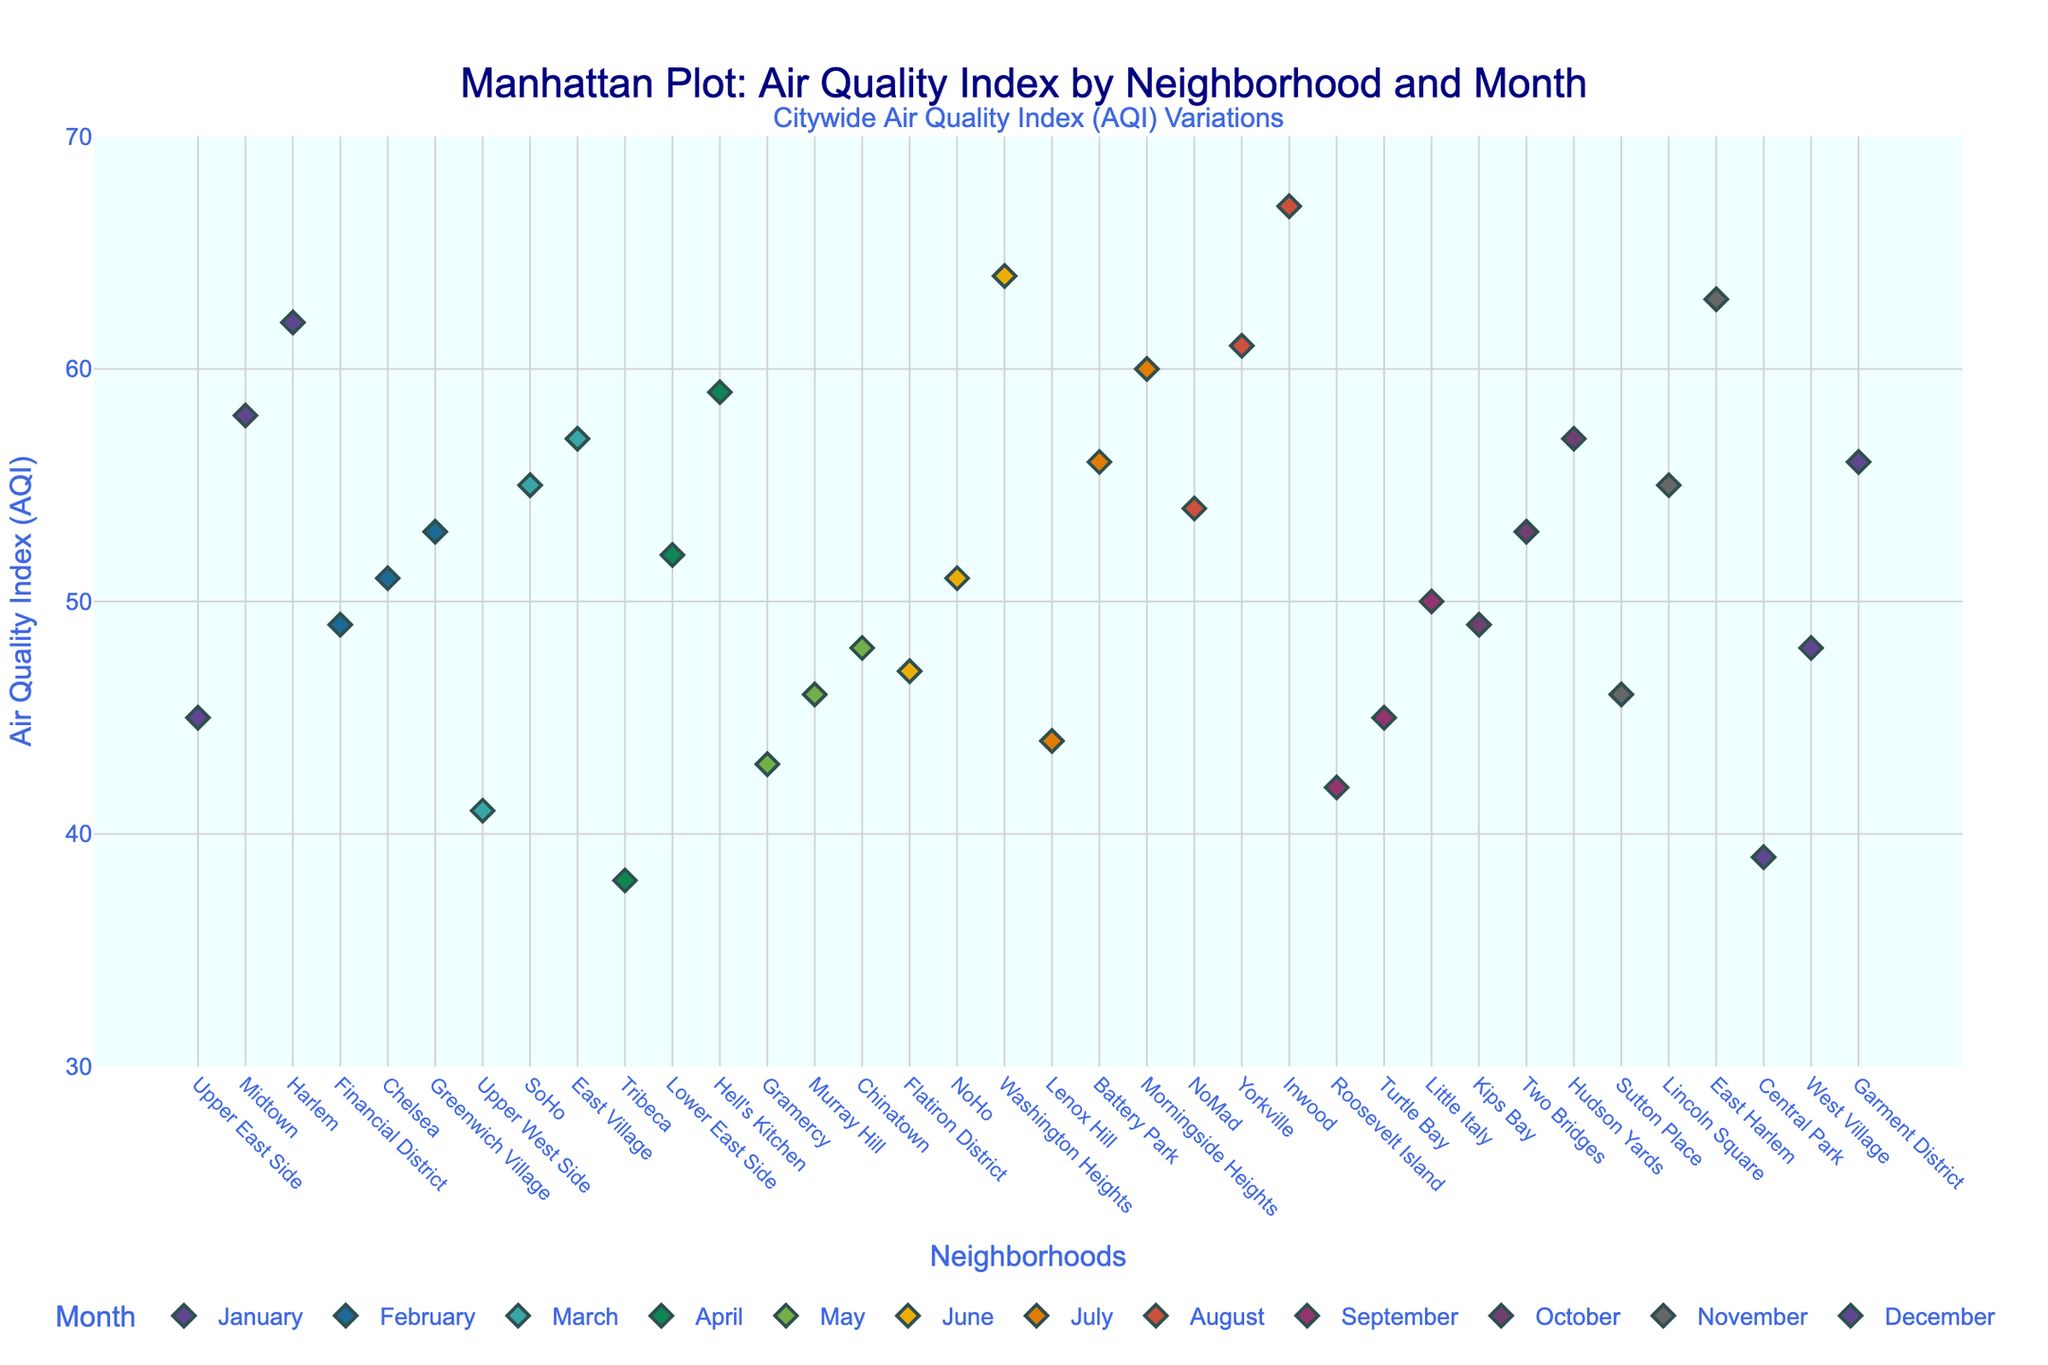Which month has the highest average AQI across all neighborhoods? Looking at the plot, identify the month with the highest average AQI by visually comparing the heights of the markers for each month. August has generally higher AQI values.
Answer: August Which neighborhood had the highest AQI in January? Look for the highest marker in January. Harlem stands out with an AQI of 62.
Answer: Harlem Which months exhibit the lowest and highest AQI ranges? Examine the spread of points (range) across neighborhoods for each month. April shows a narrow range around 38-59 (lowest), while August shows a wider range around 54-67 (highest).
Answer: April (lowest), August (highest) Is there a noticeable seasonal trend in AQI values? Look for patterns within the months grouped by seasons. Generally, winter (December-February) has lower AQI values compared to summer (June-August), indicating potential seasonal variations.
Answer: Yes, summer tends to have higher AQI Which neighborhood has the lowest AQI and in which month? Look for the lowest AQI values across the entire plot. Tribeca in April with an AQI of 38 is the lowest.
Answer: Tribeca, April How does the AQI of East Harlem in November compare to that of Greenwich Village in February? Compare their AQI values directly. East Harlem in November has an AQI of 63, whereas Greenwich Village in February has an AQI of 53. East Harlem has a higher AQI by 10.
Answer: East Harlem is higher by 10 Is there any neighborhood that appears consistently in the higher AQI range multiple months? Identify neighborhoods appearing with consistently high AQI values. Harlem and East Harlem often show higher AQI levels across multiple months.
Answer: Harlem and East Harlem On average, do neighborhoods tend to have higher AQI values in the beginning or the end of the year? Compare the general height of markers at the start (January-March) and end (October-December) of the year. The end of the year (specifically November) has generally higher AQI values.
Answer: End of the year Are there any outlier AQI values that stand out in the plot? Look for markers that are significantly higher or lower than others within their respective months. Inwood in August with an AQI of 67 is a noticeable outlier.
Answer: Inwood in August 